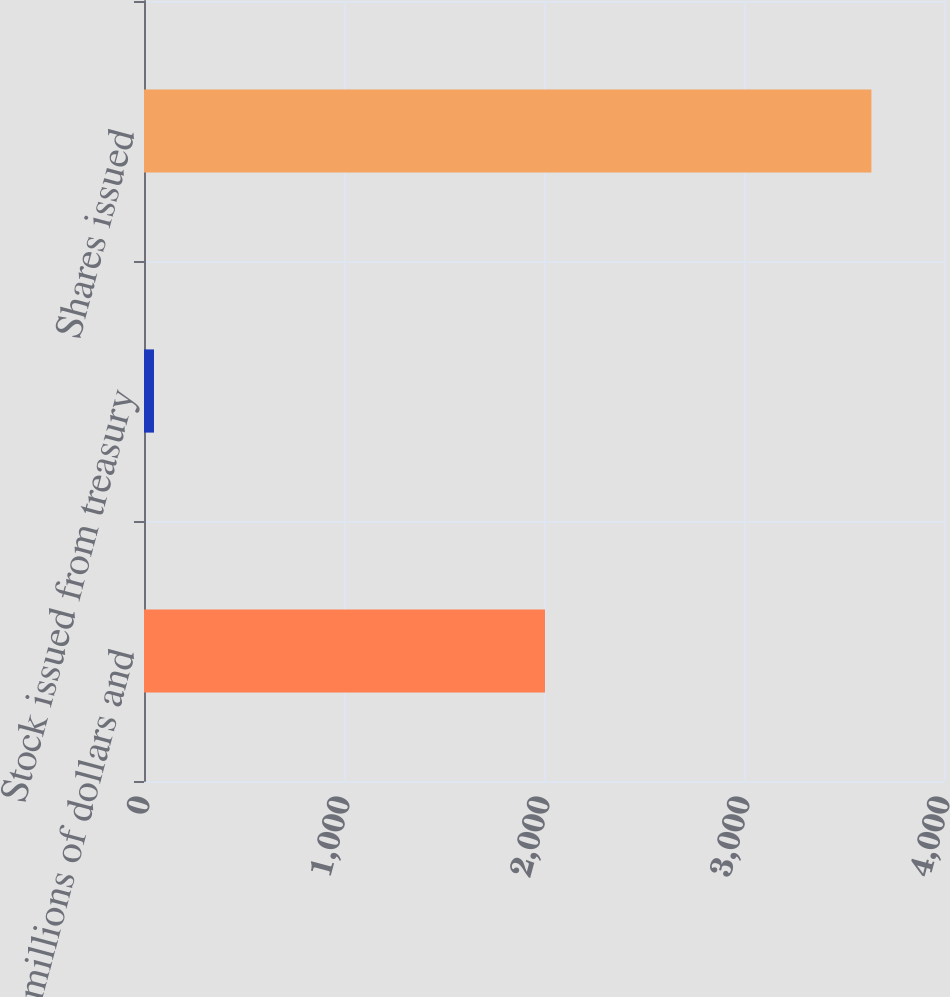Convert chart to OTSL. <chart><loc_0><loc_0><loc_500><loc_500><bar_chart><fcel>(In millions of dollars and<fcel>Stock issued from treasury<fcel>Shares issued<nl><fcel>2005<fcel>50<fcel>3637<nl></chart> 